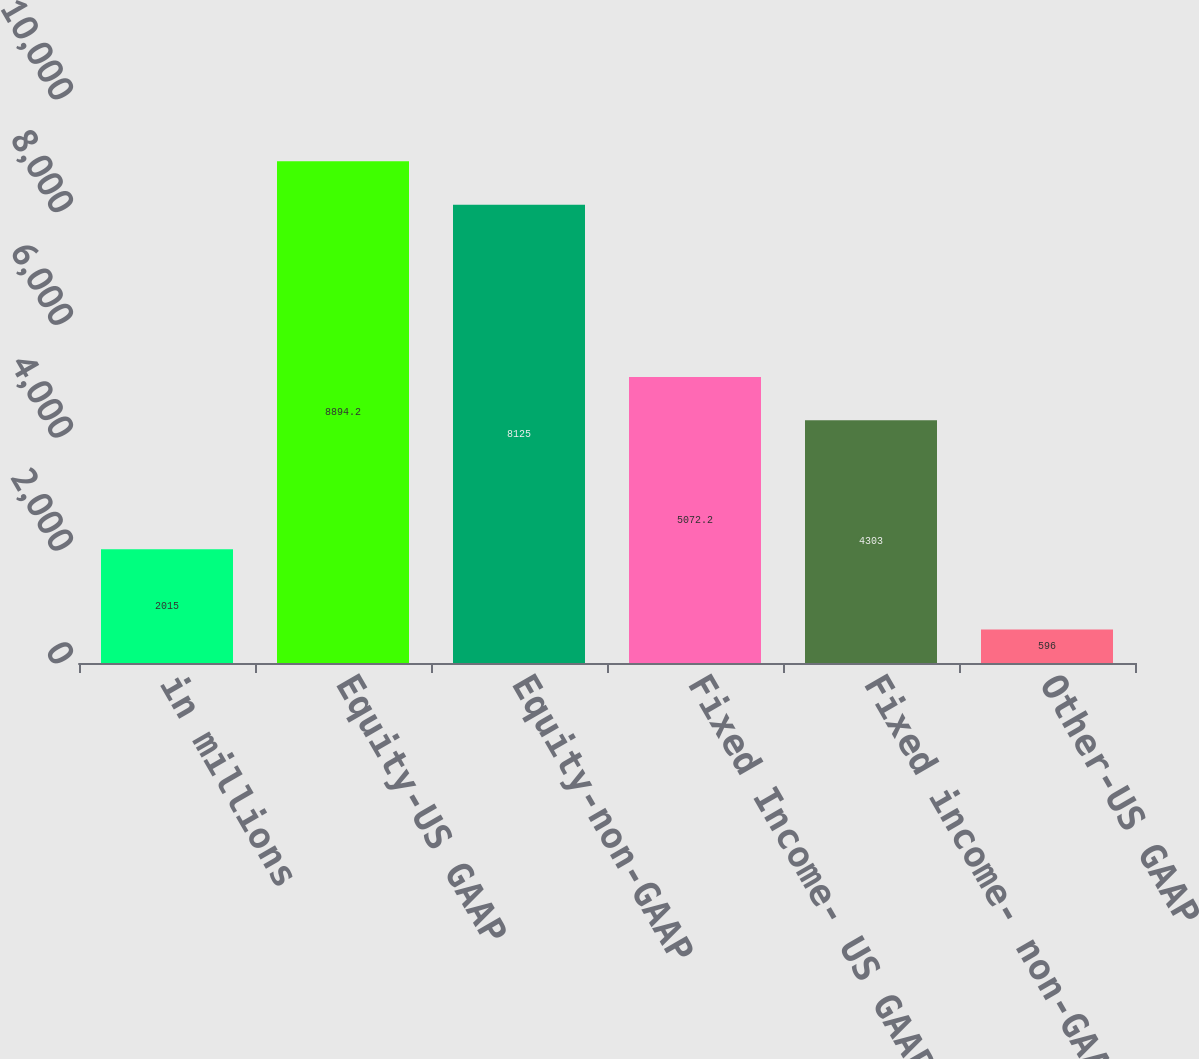Convert chart. <chart><loc_0><loc_0><loc_500><loc_500><bar_chart><fcel>in millions<fcel>Equity-US GAAP<fcel>Equity-non-GAAP<fcel>Fixed Income- US GAAP 2<fcel>Fixed income- non-GAAP<fcel>Other-US GAAP<nl><fcel>2015<fcel>8894.2<fcel>8125<fcel>5072.2<fcel>4303<fcel>596<nl></chart> 